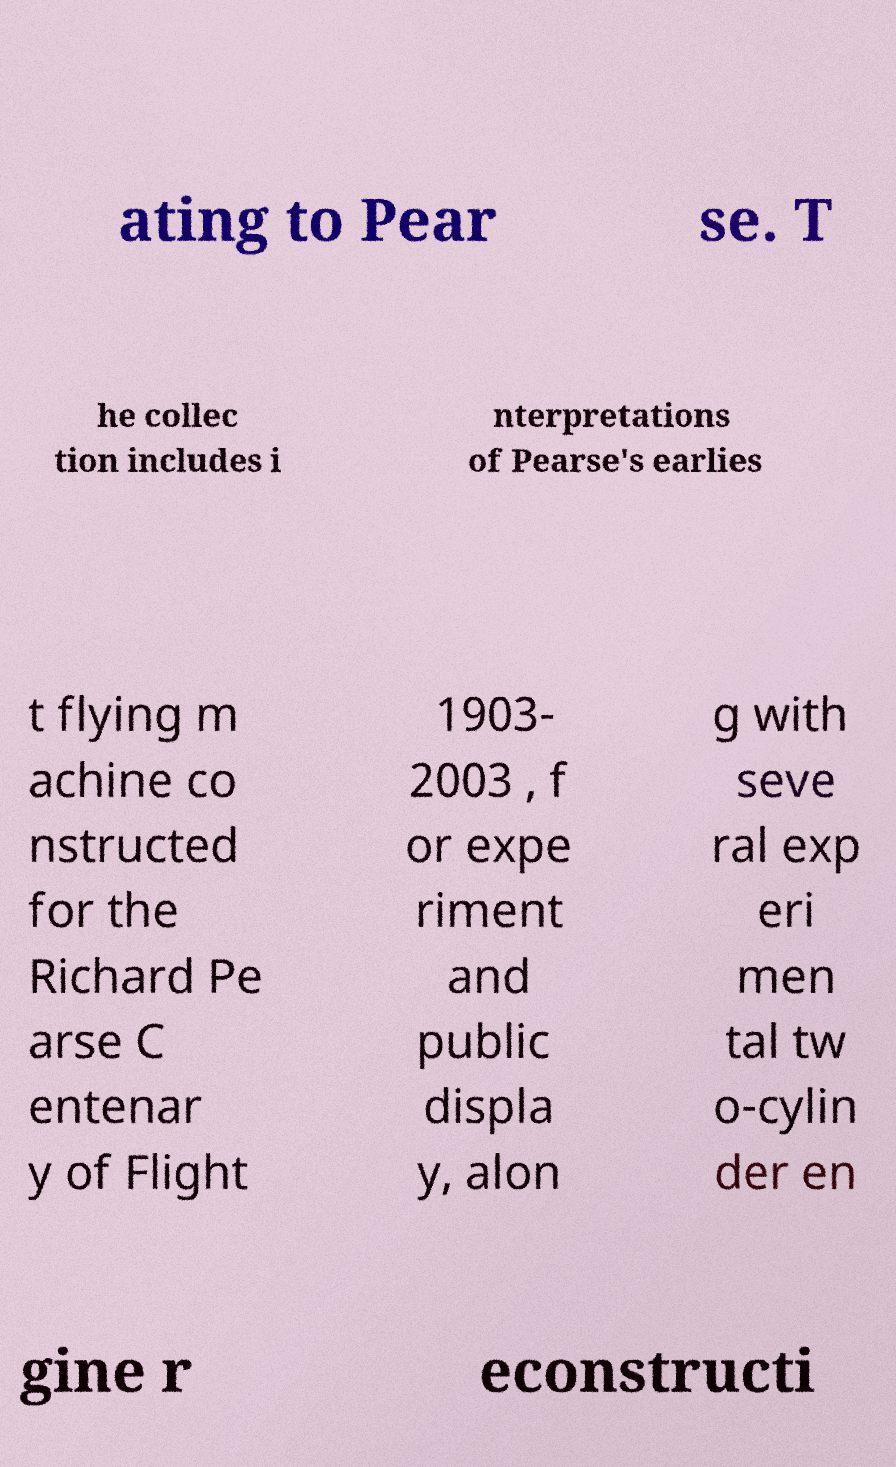Please read and relay the text visible in this image. What does it say? ating to Pear se. T he collec tion includes i nterpretations of Pearse's earlies t flying m achine co nstructed for the Richard Pe arse C entenar y of Flight 1903- 2003 , f or expe riment and public displa y, alon g with seve ral exp eri men tal tw o-cylin der en gine r econstructi 